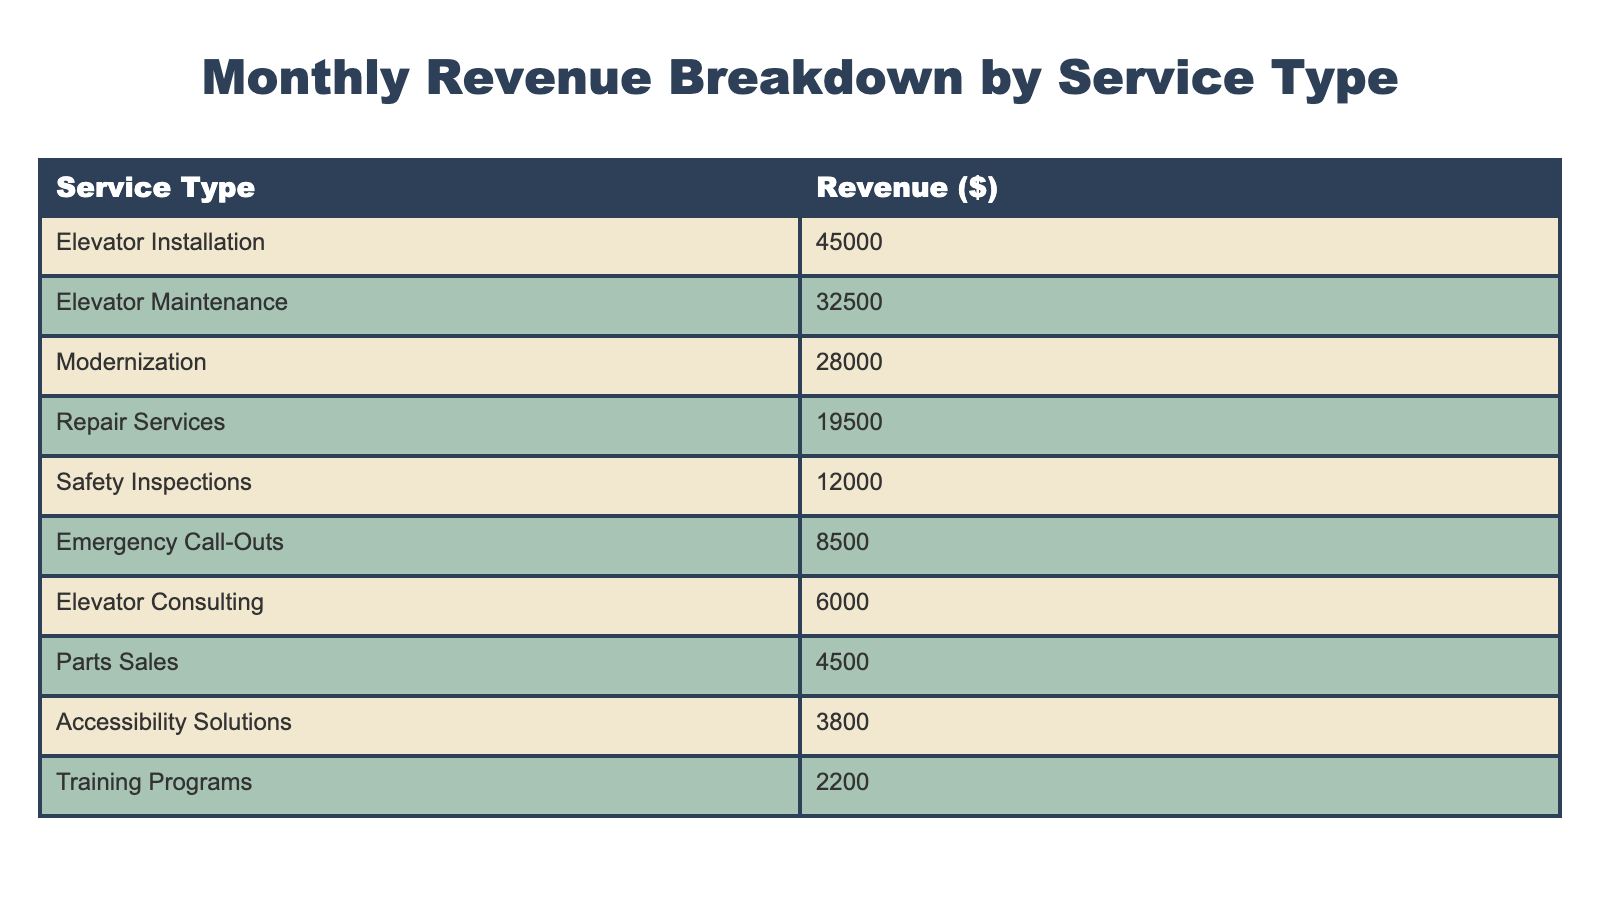What is the revenue generated from Elevator Installation? The table lists Elevator Installation under the Service Type column with a corresponding revenue of 45000 in the Revenue ($) column.
Answer: 45000 Which service type generated the lowest revenue? Looking through the Revenue ($) column, the lowest value appears under Accessibility Solutions, which has a revenue of 3800.
Answer: Accessibility Solutions What is the total revenue from Maintenance and Repair Services combined? To find the total revenue, add the revenue from Elevator Maintenance (32500) and Repair Services (19500): 32500 + 19500 = 52000.
Answer: 52000 Did Elevator Consulting generate more revenue than Emergency Call-Outs? The revenue for Elevator Consulting is 6000, and for Emergency Call-Outs, it is 8500. Since 6000 is less than 8500, the statement is false.
Answer: No What is the average revenue of all service types listed in the table? First, sum all the revenues: 45000 + 32500 + 28000 + 19500 + 12000 + 8500 + 6000 + 4500 + 3800 + 2200 = 106000. There are 10 service types, so divide the total by 10: 106000 / 10 = 10600.
Answer: 10600 Which service type contributes more to revenue, Modernization or Safety Inspections? The revenue from Modernization is 28000, while Safety Inspections is 12000. Since 28000 is greater than 12000, Modernization contributes more.
Answer: Modernization How much more revenue does Elevator Maintenance have compared to Parts Sales? Elevator Maintenance has a revenue of 32500 while Parts Sales has 4500. To find the difference, subtract: 32500 - 4500 = 28000.
Answer: 28000 What percentage of the total revenue is generated by Emergency Call-Outs? First, find the total revenue which was previously calculated as 106000. Emergency Call-Outs generated 8500. To find the percentage: (8500 / 106000) * 100 = 8.49%.
Answer: 8.49% 